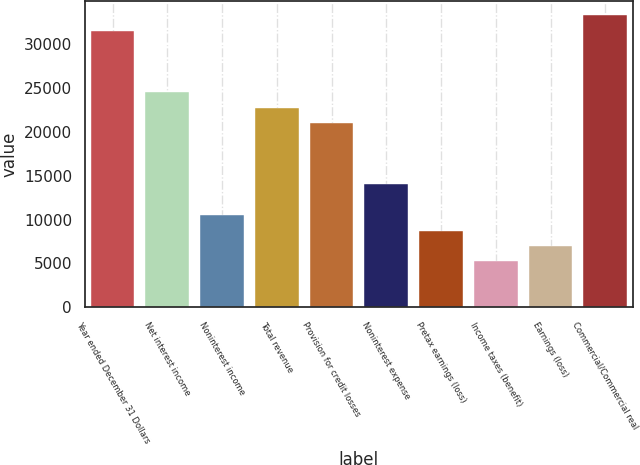<chart> <loc_0><loc_0><loc_500><loc_500><bar_chart><fcel>Year ended December 31 Dollars<fcel>Net interest income<fcel>Noninterest income<fcel>Total revenue<fcel>Provision for credit losses<fcel>Noninterest expense<fcel>Pretax earnings (loss)<fcel>Income taxes (benefit)<fcel>Earnings (loss)<fcel>Commercial/Commercial real<nl><fcel>31530.4<fcel>24523.7<fcel>10510.4<fcel>22772<fcel>21020.4<fcel>14013.7<fcel>8758.68<fcel>5255.34<fcel>7007.01<fcel>33282.1<nl></chart> 